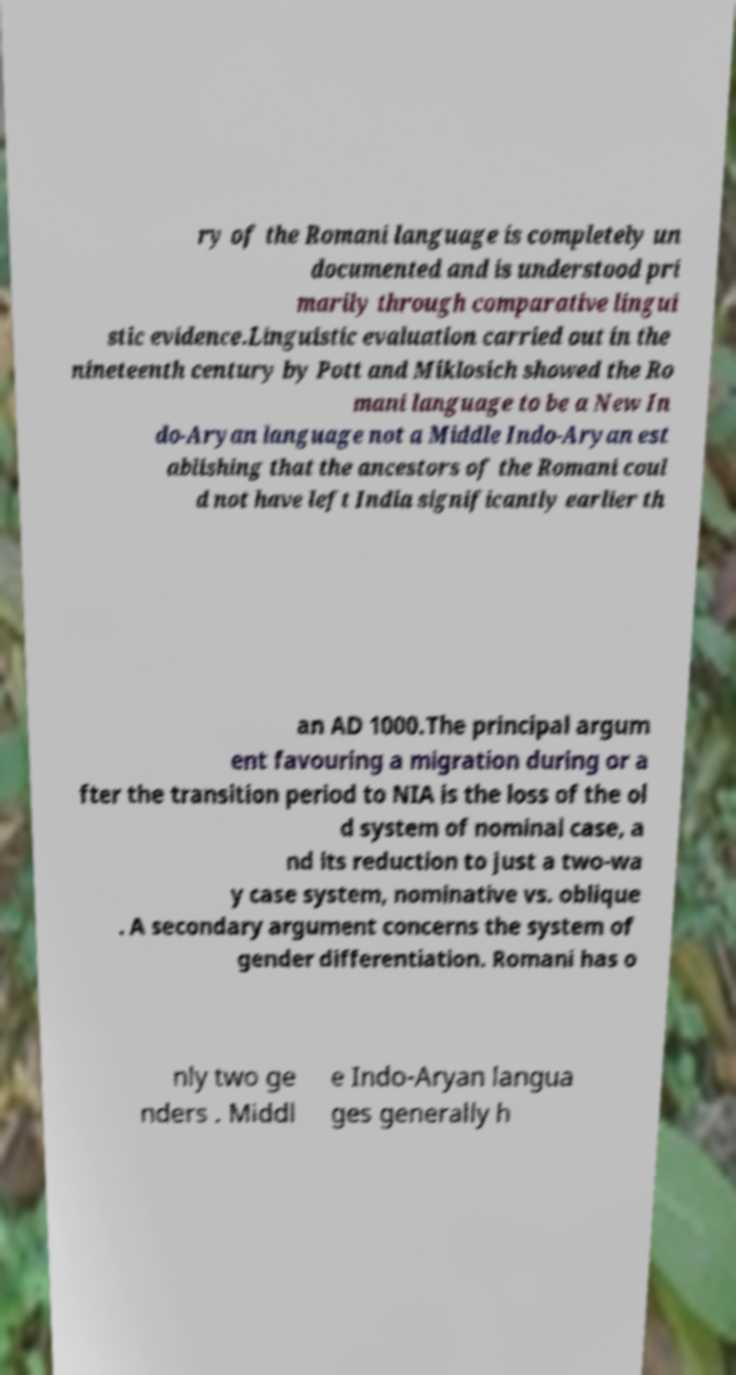Can you accurately transcribe the text from the provided image for me? ry of the Romani language is completely un documented and is understood pri marily through comparative lingui stic evidence.Linguistic evaluation carried out in the nineteenth century by Pott and Miklosich showed the Ro mani language to be a New In do-Aryan language not a Middle Indo-Aryan est ablishing that the ancestors of the Romani coul d not have left India significantly earlier th an AD 1000.The principal argum ent favouring a migration during or a fter the transition period to NIA is the loss of the ol d system of nominal case, a nd its reduction to just a two-wa y case system, nominative vs. oblique . A secondary argument concerns the system of gender differentiation. Romani has o nly two ge nders . Middl e Indo-Aryan langua ges generally h 